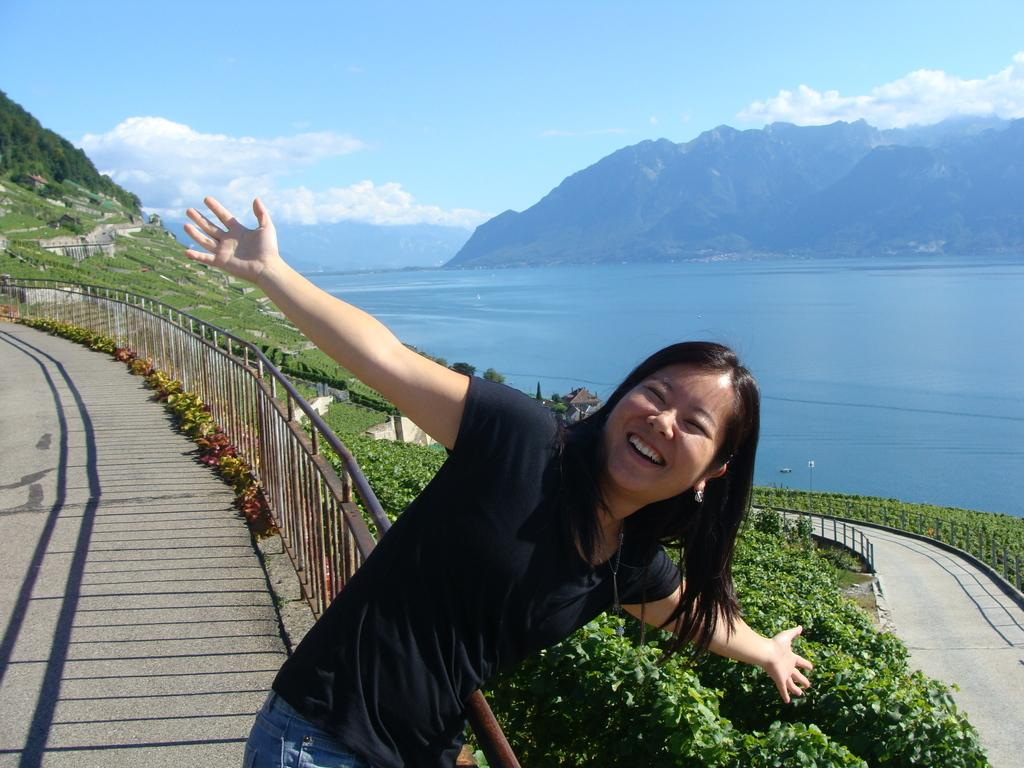What is the woman doing in the image? The woman is standing and smiling in the image. What can be seen in the background of the image? The sky with clouds is visible in the background of the image. What type of natural features are present in the image? There are trees, mountains, and water visible in the image. What man-made structures can be seen in the image? There is a fence in the image. Is there a path in the image? Yes, there is a path in the image. How does the woman increase the speed of the watch in the image? There is no watch present in the image, so it is not possible to determine how the woman might increase its speed. 